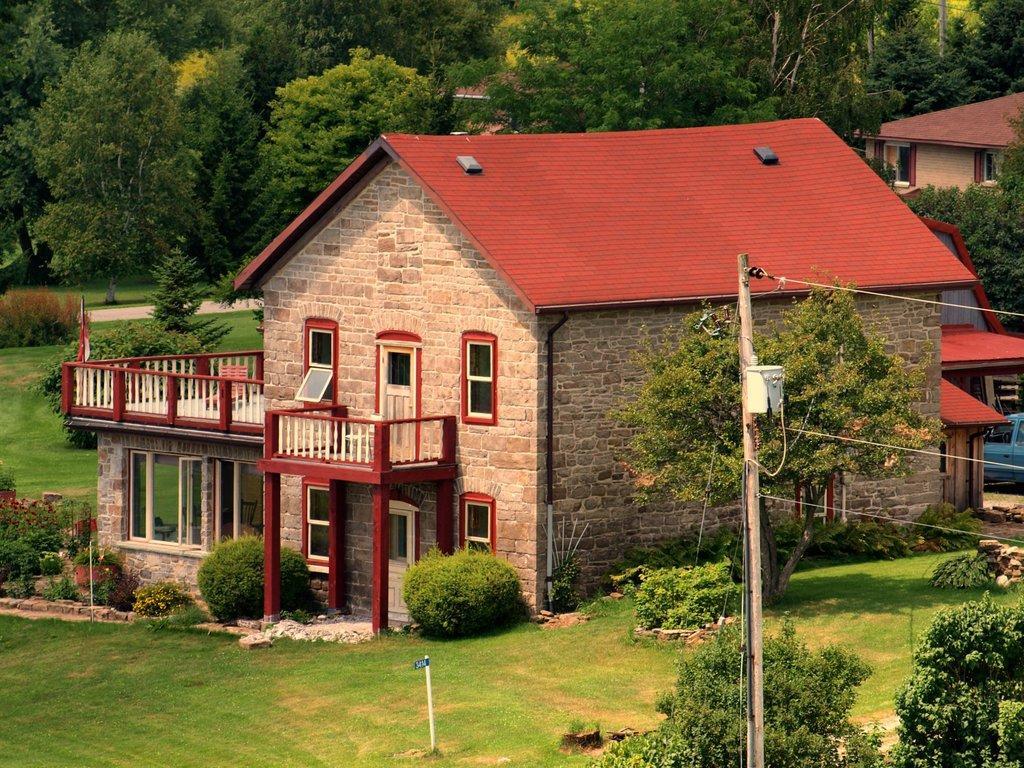How would you summarize this image in a sentence or two? In this image there are buildings. In front of the building there are hedges. Beside the building there are plants and trees. To the right there is a car. There is grass on the ground. There is an electric pole in the image. In the background there are trees. 